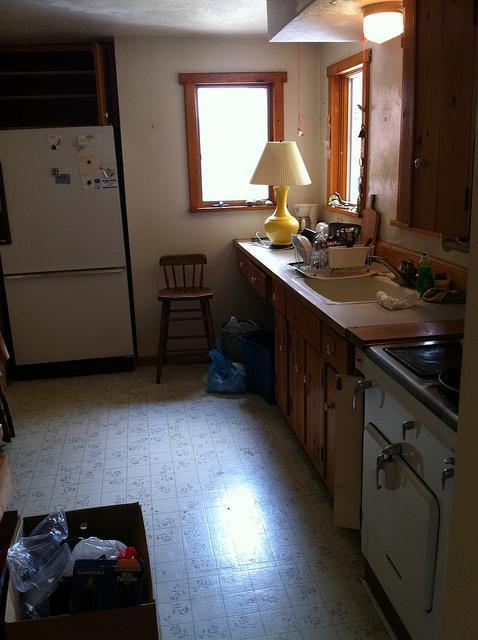How many cabinet doors are open?
Give a very brief answer. 0. How many books are on the bookshelves?
Give a very brief answer. 0. How many lights on?
Give a very brief answer. 1. How many hanging lights are visible?
Give a very brief answer. 1. How many sinks can be seen?
Give a very brief answer. 1. How many people are wearing a tie in the picture?
Give a very brief answer. 0. 